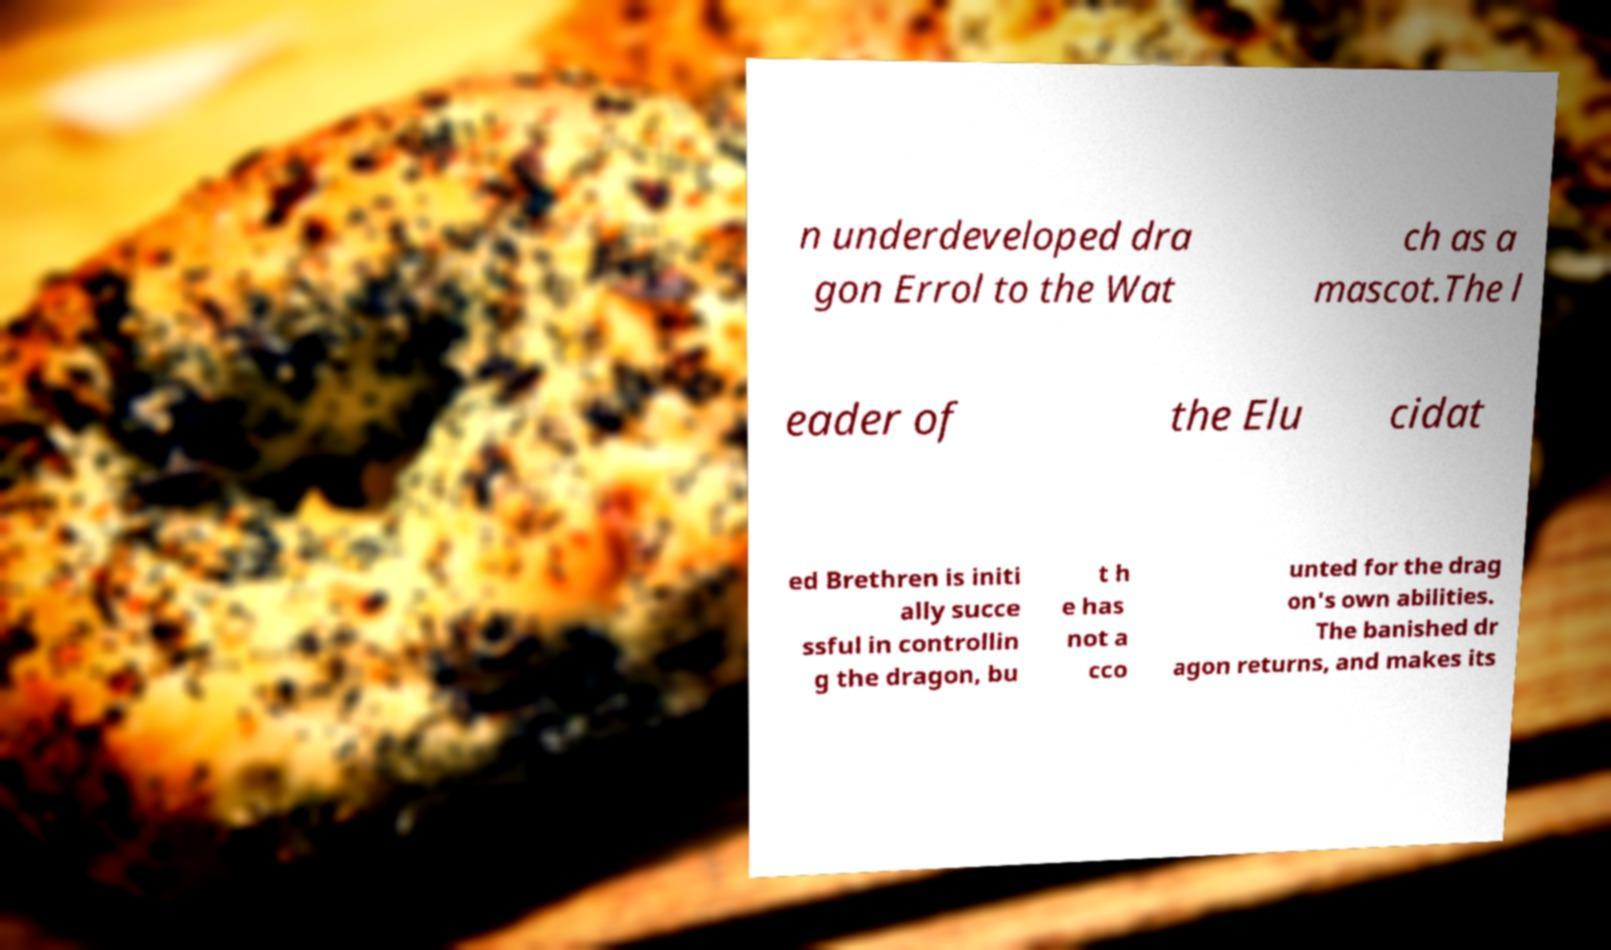What messages or text are displayed in this image? I need them in a readable, typed format. n underdeveloped dra gon Errol to the Wat ch as a mascot.The l eader of the Elu cidat ed Brethren is initi ally succe ssful in controllin g the dragon, bu t h e has not a cco unted for the drag on's own abilities. The banished dr agon returns, and makes its 